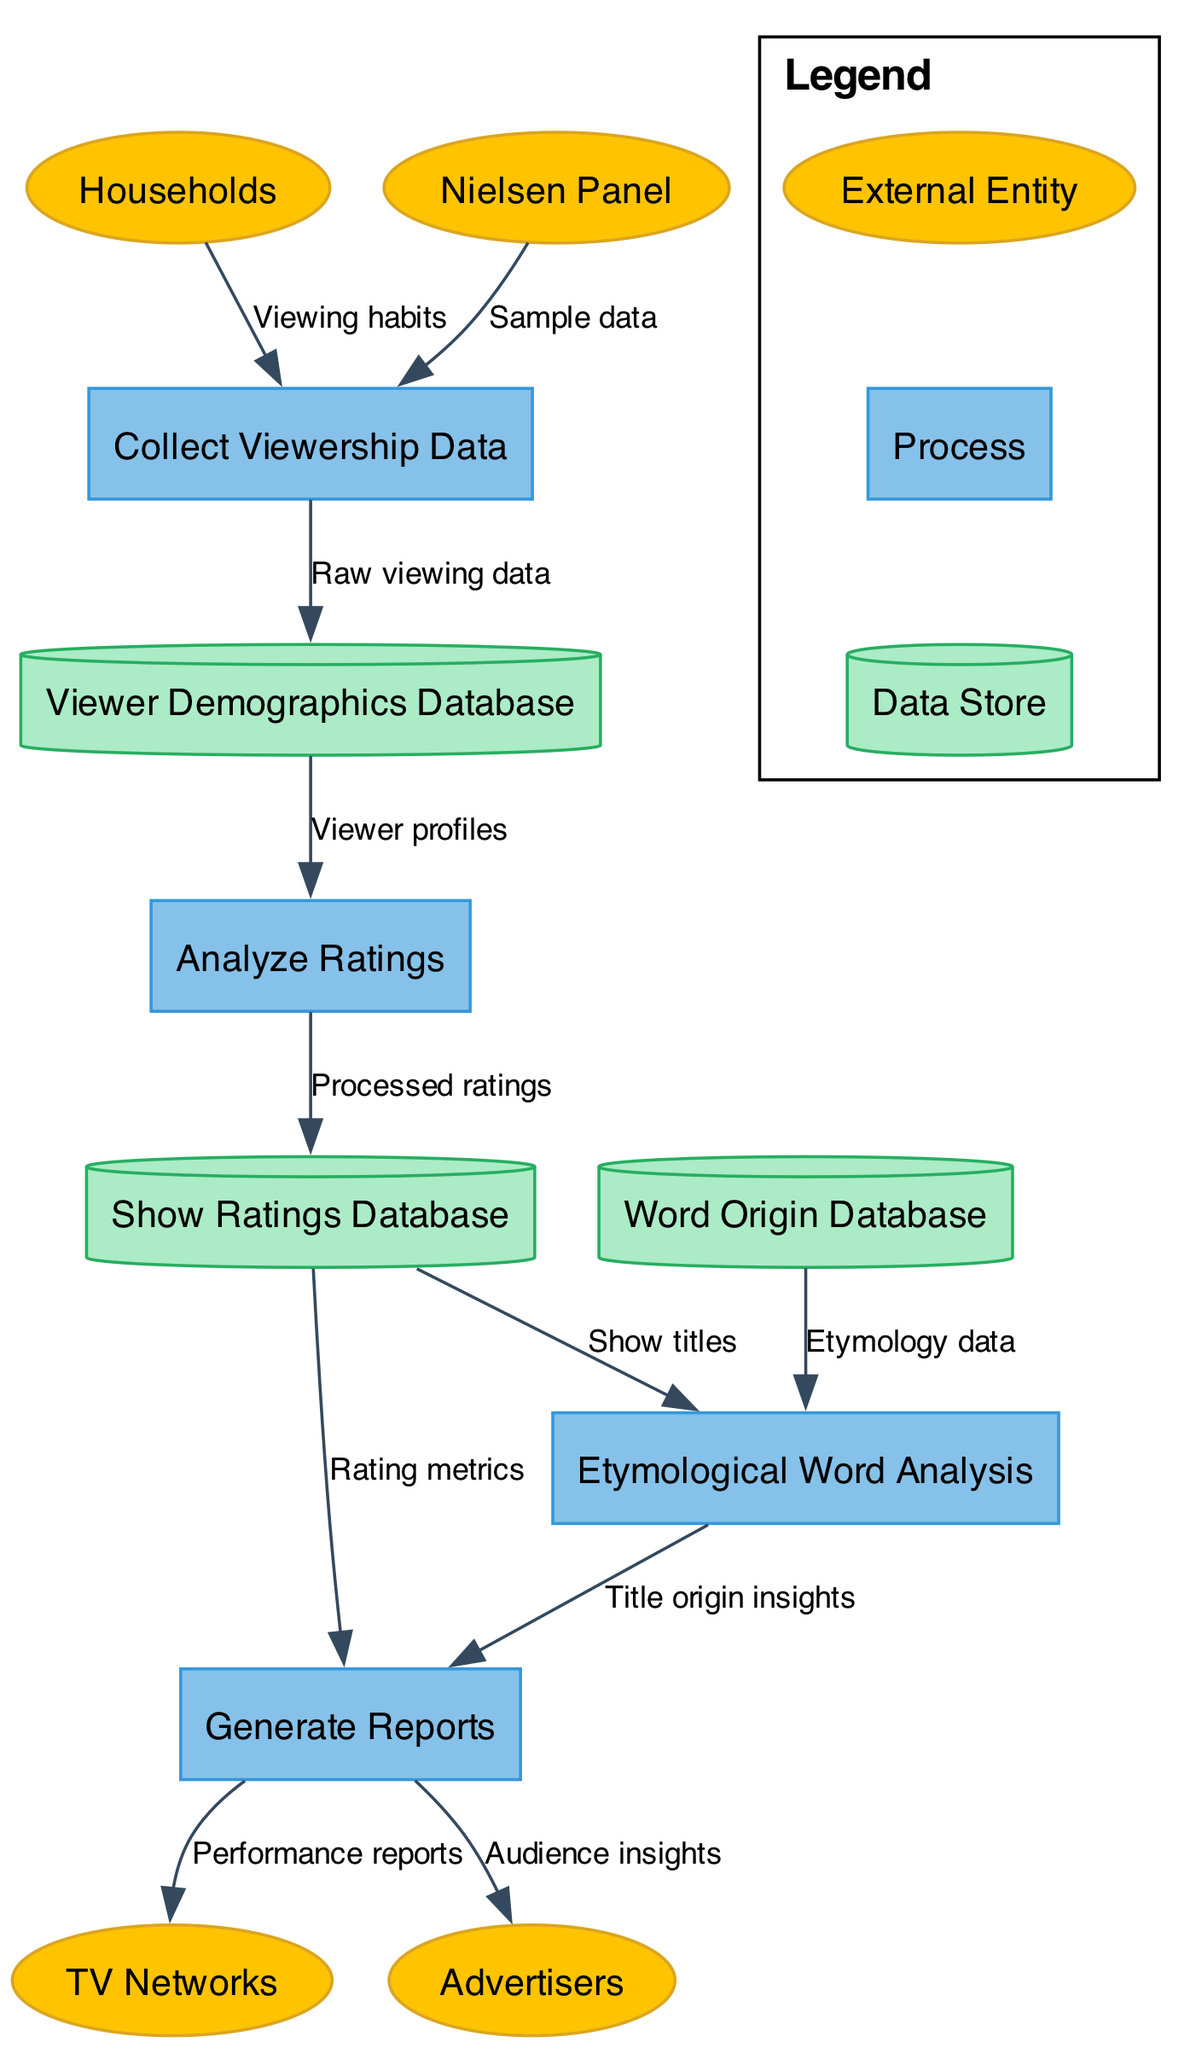What is the total number of external entities in the diagram? The diagram lists four external entities: Households, Nielsen Panel, TV Networks, and Advertisers. By counting them, we find there are a total of four.
Answer: 4 Which process receives data directly from the Viewer Demographics Database? The "Analyze Ratings" process receives viewer profiles directly from the Viewer Demographics Database. This relationship is indicated by an arrow from the data store to the process.
Answer: Analyze Ratings What type of data flows from the Generate Reports process to the TV Networks entity? The data flow label from Generate Reports to TV Networks is "Performance reports." This indicates that the reports generated are specifically about the performance of TV shows.
Answer: Performance reports How many data stores are referenced in the diagram? The diagram includes three data stores: Viewer Demographics Database, Show Ratings Database, and Word Origin Database. Counting these gives a total of three data stores.
Answer: 3 What is the relationship between the Analyze Ratings process and the Show Ratings Database? The Analyze Ratings process outputs "Processed ratings" to the Show Ratings Database. This indicates that the ratings that have been analyzed are stored here.
Answer: Processed ratings What type of analysis is performed using data from the Show Ratings Database? The process "Etymological Word Analysis" uses show titles from the Show Ratings Database. This analysis likely focuses on the origins of words in the titles of shows.
Answer: Etymological Word Analysis Which external entity receives audience insights generated by the Generate Reports process? Advertisers receive the audience insights from the Generate Reports process, as indicated by the direct data flow shown in the diagram.
Answer: Advertisers What flow of data occurs between the Word Origin Database and Etymological Word Analysis? The flow of data from the Word Origin Database to Etymological Word Analysis consists of "Etymology data." This means that the analysis draws from this specific type of data.
Answer: Etymology data In how many different processes does the Show Ratings Database participate? The Show Ratings Database is involved in three processes: Analyze Ratings, Generate Reports, and Etymological Word Analysis. This interaction across various processes demonstrates its integral role.
Answer: 3 